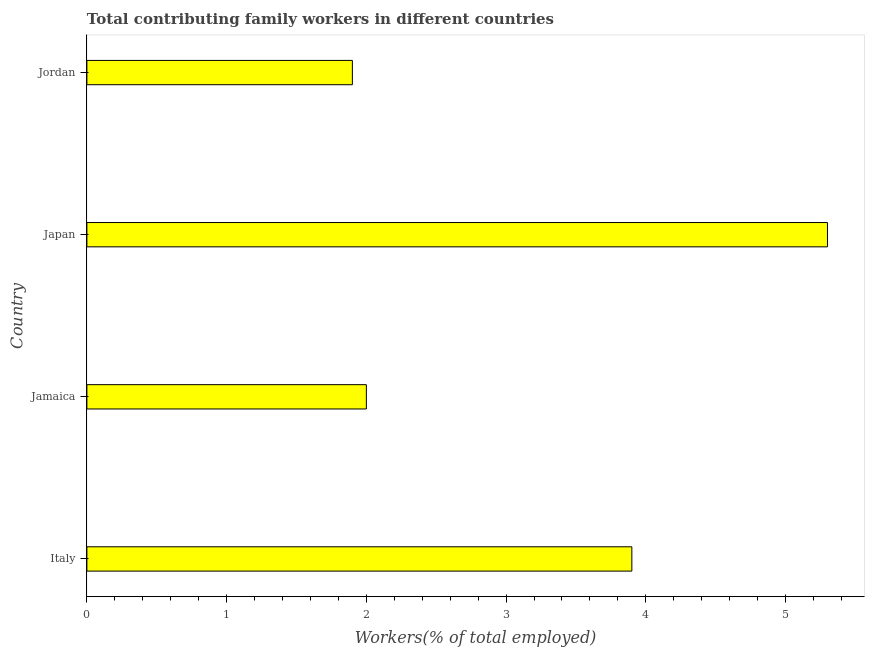Does the graph contain any zero values?
Provide a short and direct response. No. Does the graph contain grids?
Provide a short and direct response. No. What is the title of the graph?
Your answer should be very brief. Total contributing family workers in different countries. What is the label or title of the X-axis?
Offer a terse response. Workers(% of total employed). What is the contributing family workers in Japan?
Your response must be concise. 5.3. Across all countries, what is the maximum contributing family workers?
Make the answer very short. 5.3. Across all countries, what is the minimum contributing family workers?
Keep it short and to the point. 1.9. In which country was the contributing family workers maximum?
Your response must be concise. Japan. In which country was the contributing family workers minimum?
Offer a terse response. Jordan. What is the sum of the contributing family workers?
Provide a short and direct response. 13.1. What is the difference between the contributing family workers in Japan and Jordan?
Your response must be concise. 3.4. What is the average contributing family workers per country?
Offer a terse response. 3.27. What is the median contributing family workers?
Your response must be concise. 2.95. What is the ratio of the contributing family workers in Japan to that in Jordan?
Provide a short and direct response. 2.79. Is the contributing family workers in Jamaica less than that in Jordan?
Provide a succinct answer. No. Is the difference between the contributing family workers in Italy and Japan greater than the difference between any two countries?
Offer a terse response. No. What is the difference between the highest and the second highest contributing family workers?
Offer a terse response. 1.4. Is the sum of the contributing family workers in Jamaica and Jordan greater than the maximum contributing family workers across all countries?
Make the answer very short. No. In how many countries, is the contributing family workers greater than the average contributing family workers taken over all countries?
Make the answer very short. 2. How many bars are there?
Make the answer very short. 4. Are all the bars in the graph horizontal?
Offer a terse response. Yes. How many countries are there in the graph?
Your answer should be compact. 4. What is the Workers(% of total employed) in Italy?
Provide a short and direct response. 3.9. What is the Workers(% of total employed) of Jamaica?
Offer a very short reply. 2. What is the Workers(% of total employed) of Japan?
Provide a short and direct response. 5.3. What is the Workers(% of total employed) of Jordan?
Offer a terse response. 1.9. What is the difference between the Workers(% of total employed) in Italy and Jamaica?
Make the answer very short. 1.9. What is the difference between the Workers(% of total employed) in Italy and Jordan?
Ensure brevity in your answer.  2. What is the difference between the Workers(% of total employed) in Jamaica and Jordan?
Your answer should be very brief. 0.1. What is the difference between the Workers(% of total employed) in Japan and Jordan?
Ensure brevity in your answer.  3.4. What is the ratio of the Workers(% of total employed) in Italy to that in Jamaica?
Provide a succinct answer. 1.95. What is the ratio of the Workers(% of total employed) in Italy to that in Japan?
Offer a very short reply. 0.74. What is the ratio of the Workers(% of total employed) in Italy to that in Jordan?
Your response must be concise. 2.05. What is the ratio of the Workers(% of total employed) in Jamaica to that in Japan?
Keep it short and to the point. 0.38. What is the ratio of the Workers(% of total employed) in Jamaica to that in Jordan?
Provide a succinct answer. 1.05. What is the ratio of the Workers(% of total employed) in Japan to that in Jordan?
Keep it short and to the point. 2.79. 